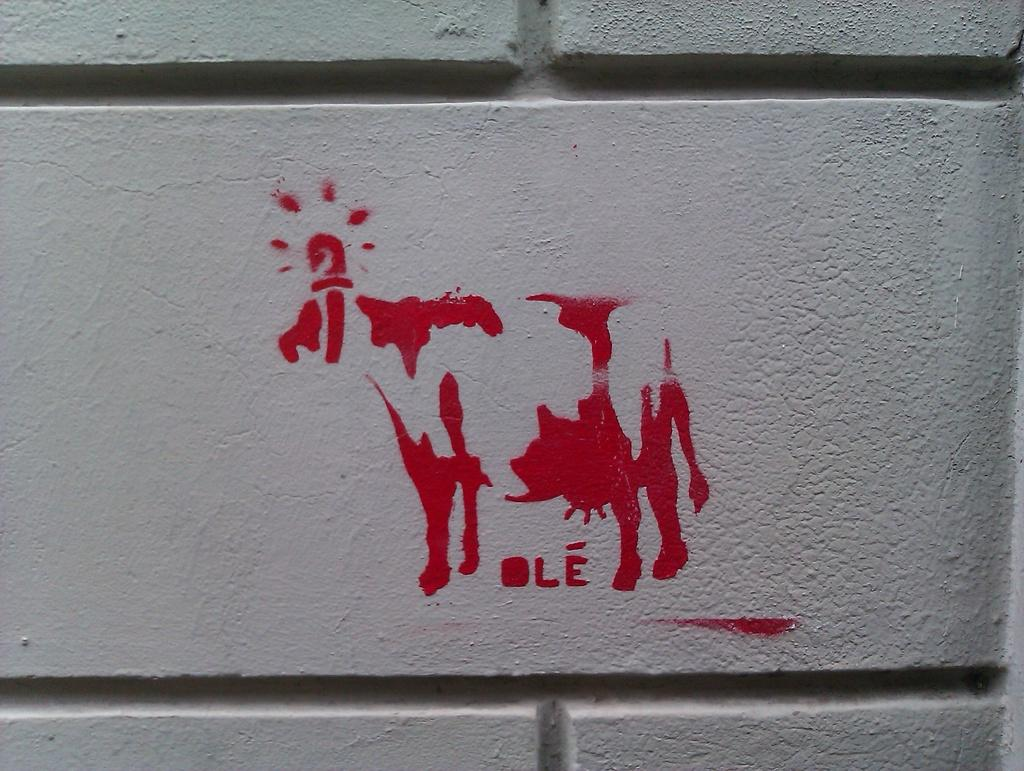What is the main subject of the image? There is a part of a wall in the image. What is on the wall? There is a painting on the wall. What does the painting depict? The painting depicts a cow. What color is the cow in the painting? The cow in the painting is red in color. What type of bread can be seen in the painting? There is no bread present in the painting; it depicts a red cow. 